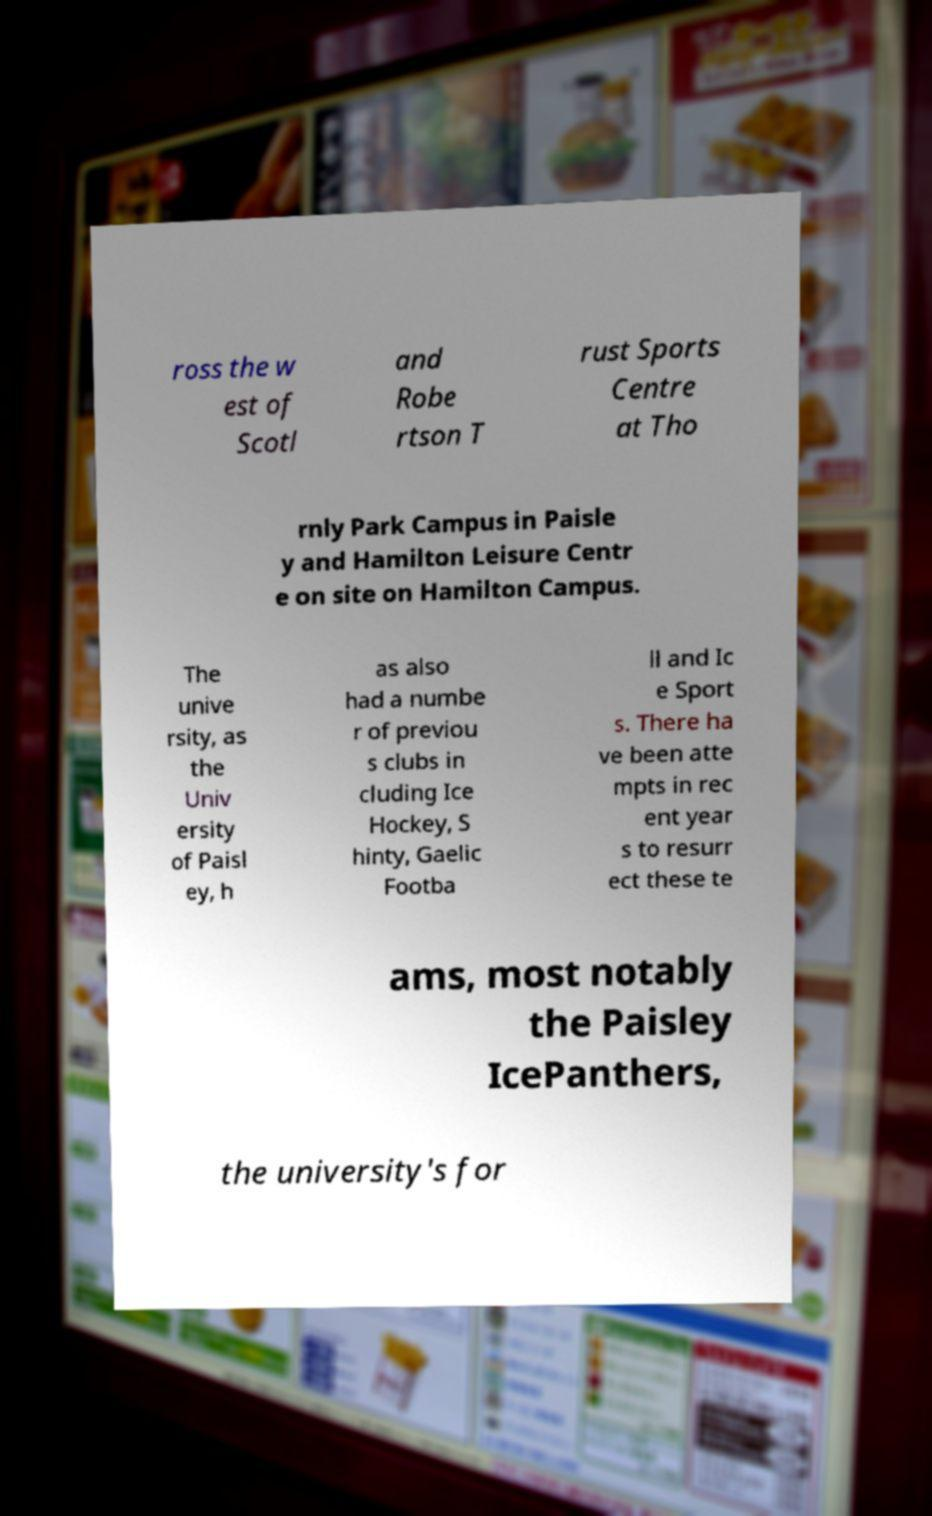What messages or text are displayed in this image? I need them in a readable, typed format. ross the w est of Scotl and Robe rtson T rust Sports Centre at Tho rnly Park Campus in Paisle y and Hamilton Leisure Centr e on site on Hamilton Campus. The unive rsity, as the Univ ersity of Paisl ey, h as also had a numbe r of previou s clubs in cluding Ice Hockey, S hinty, Gaelic Footba ll and Ic e Sport s. There ha ve been atte mpts in rec ent year s to resurr ect these te ams, most notably the Paisley IcePanthers, the university's for 